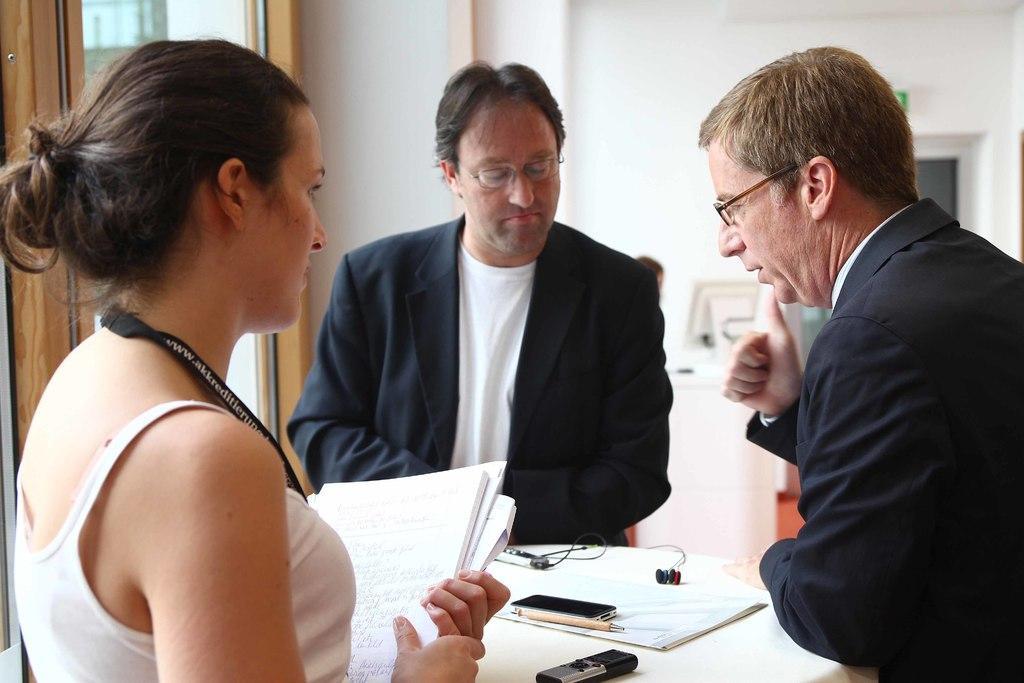Could you give a brief overview of what you see in this image? In this image, we can see three persons. Here a woman holding some papers. At the bottom of the image, there are few objects and devices are placed on the white cloth. Background we can see wall, glass object, person, monitor and few things. 